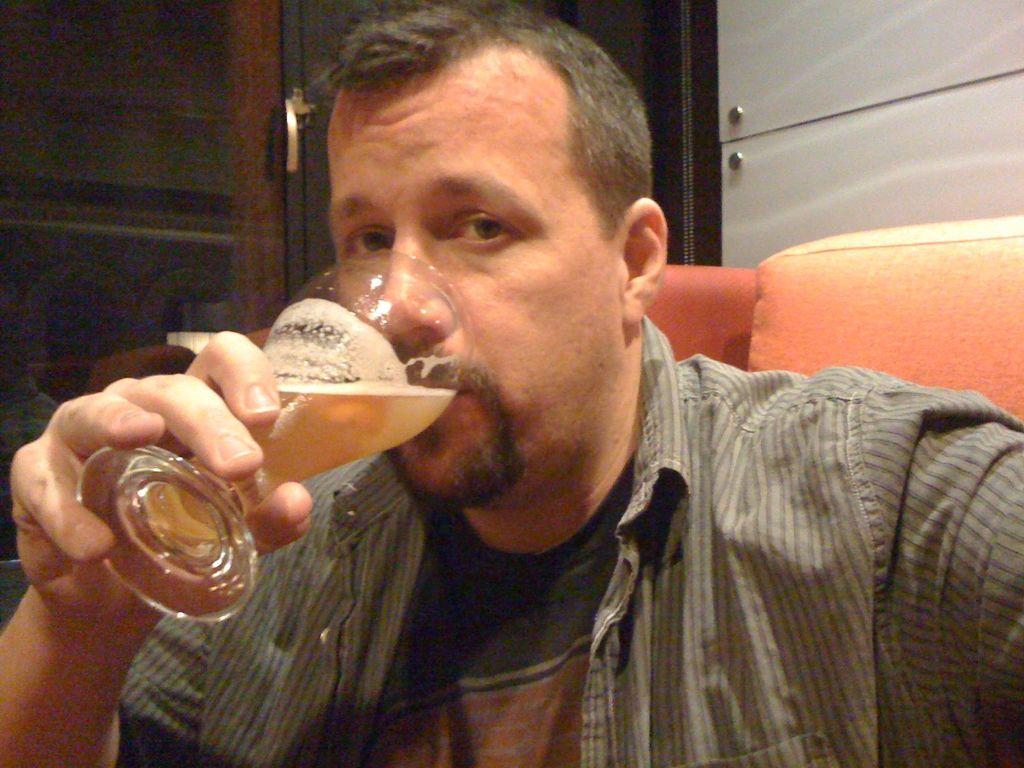How would you summarize this image in a sentence or two? Man in black t-shirt and grey color shirt is drinking wine from the glass and this guy is sitting on the sofa. Behind him, we find a dark brown color door and a white color cupboard. 